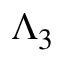Convert formula to latex. <formula><loc_0><loc_0><loc_500><loc_500>\Lambda _ { 3 }</formula> 